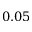Convert formula to latex. <formula><loc_0><loc_0><loc_500><loc_500>0 . 0 5</formula> 